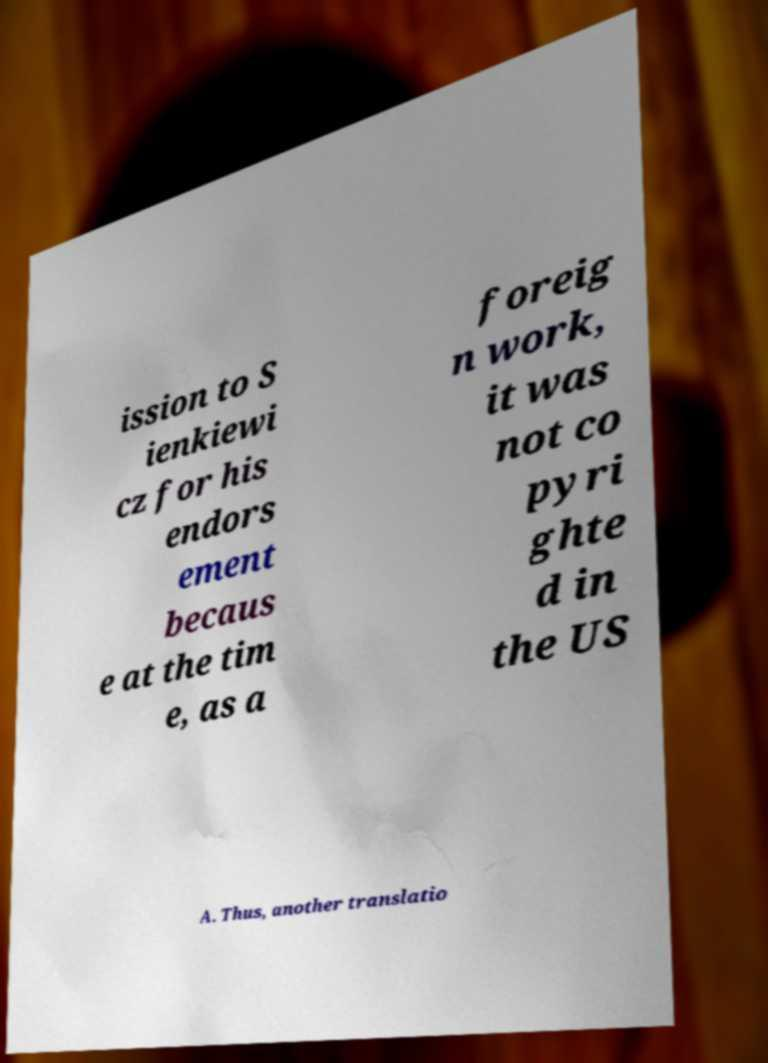Could you extract and type out the text from this image? ission to S ienkiewi cz for his endors ement becaus e at the tim e, as a foreig n work, it was not co pyri ghte d in the US A. Thus, another translatio 